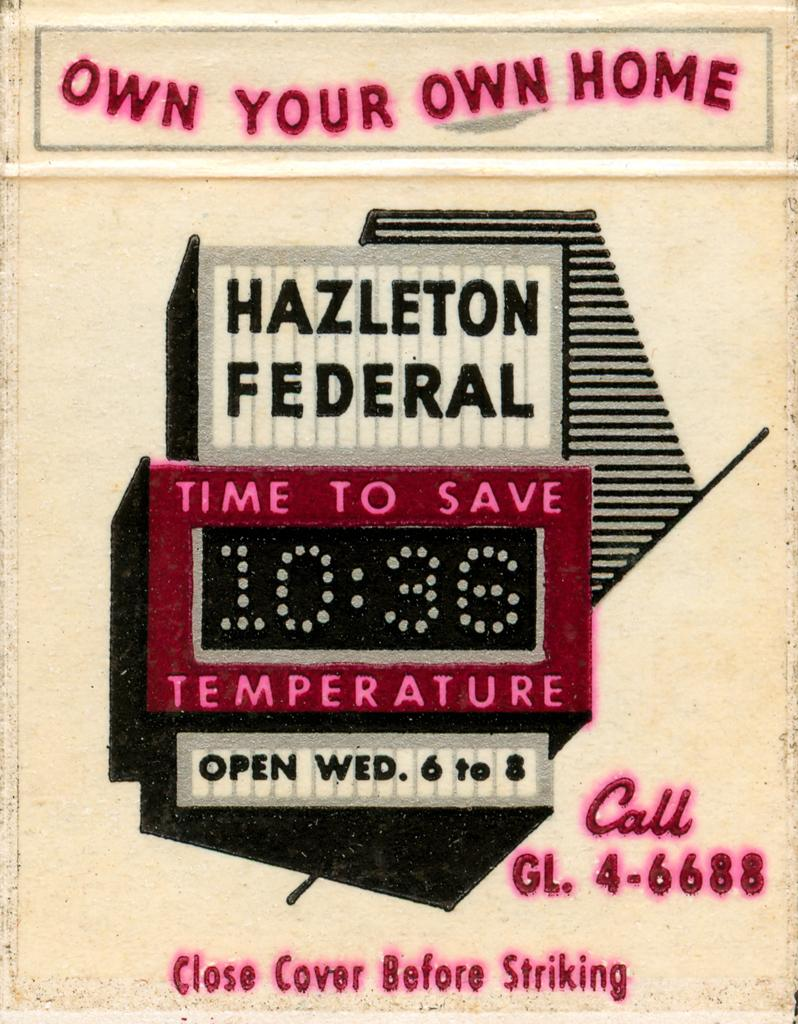<image>
Summarize the visual content of the image. An advertisement for Hazleton Federal says the time is 10:36. 